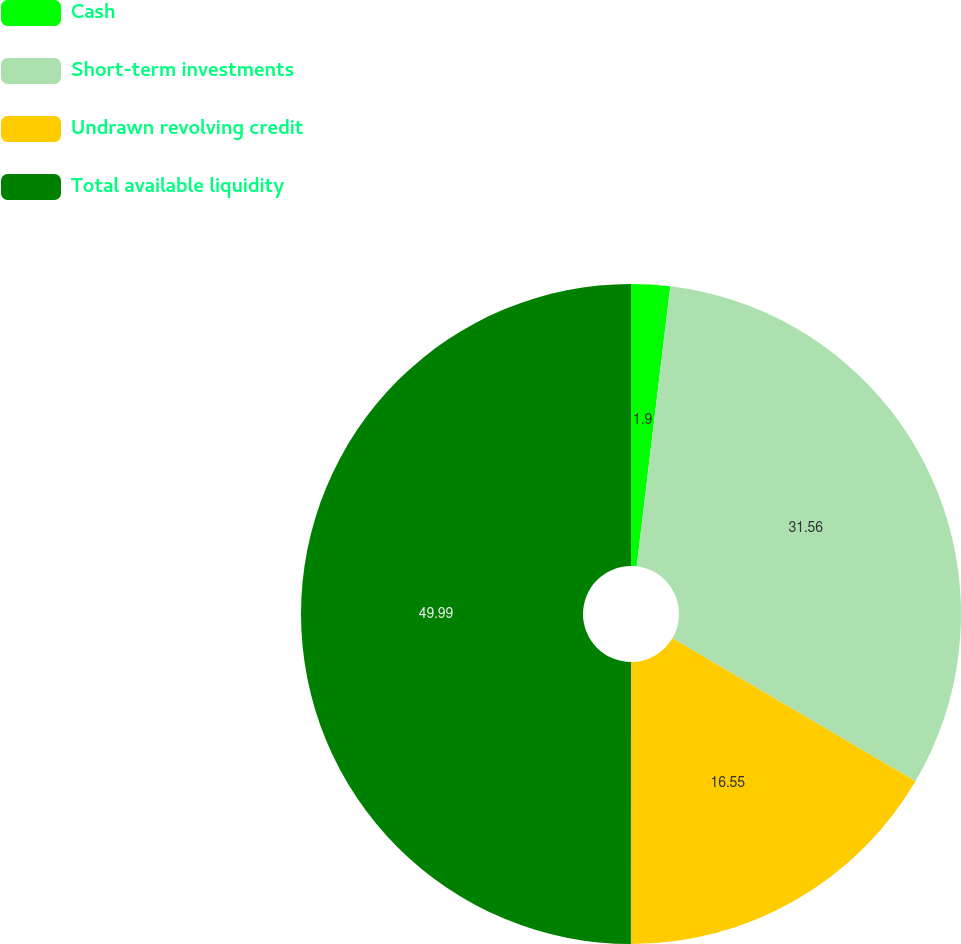Convert chart. <chart><loc_0><loc_0><loc_500><loc_500><pie_chart><fcel>Cash<fcel>Short-term investments<fcel>Undrawn revolving credit<fcel>Total available liquidity<nl><fcel>1.9%<fcel>31.56%<fcel>16.55%<fcel>50.0%<nl></chart> 